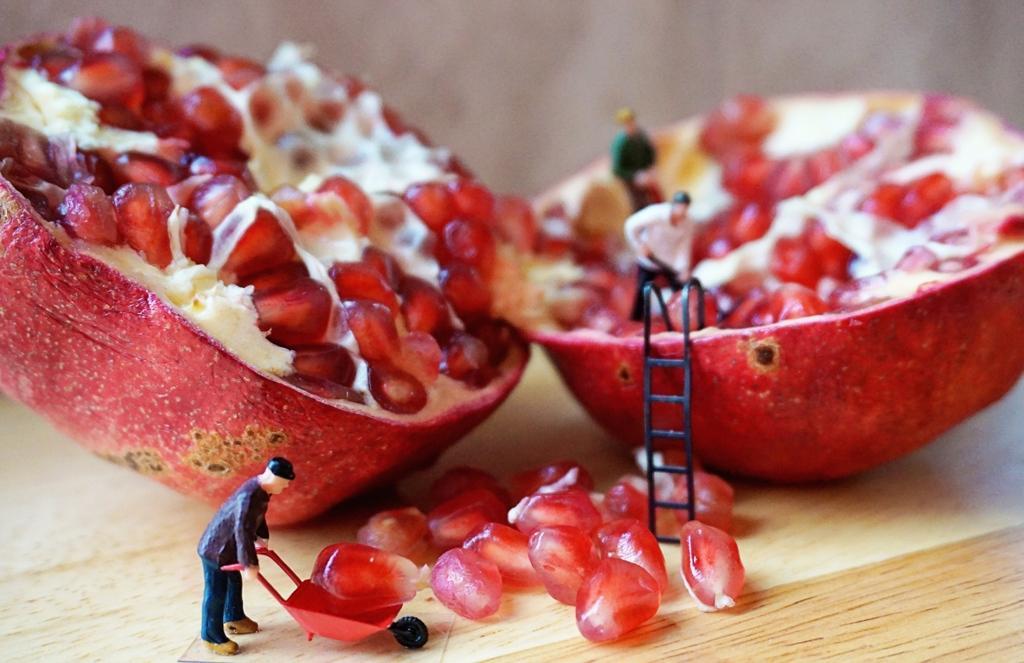Describe this image in one or two sentences. In this image there is a table, on that table there is a pomegranate and there are toys. 